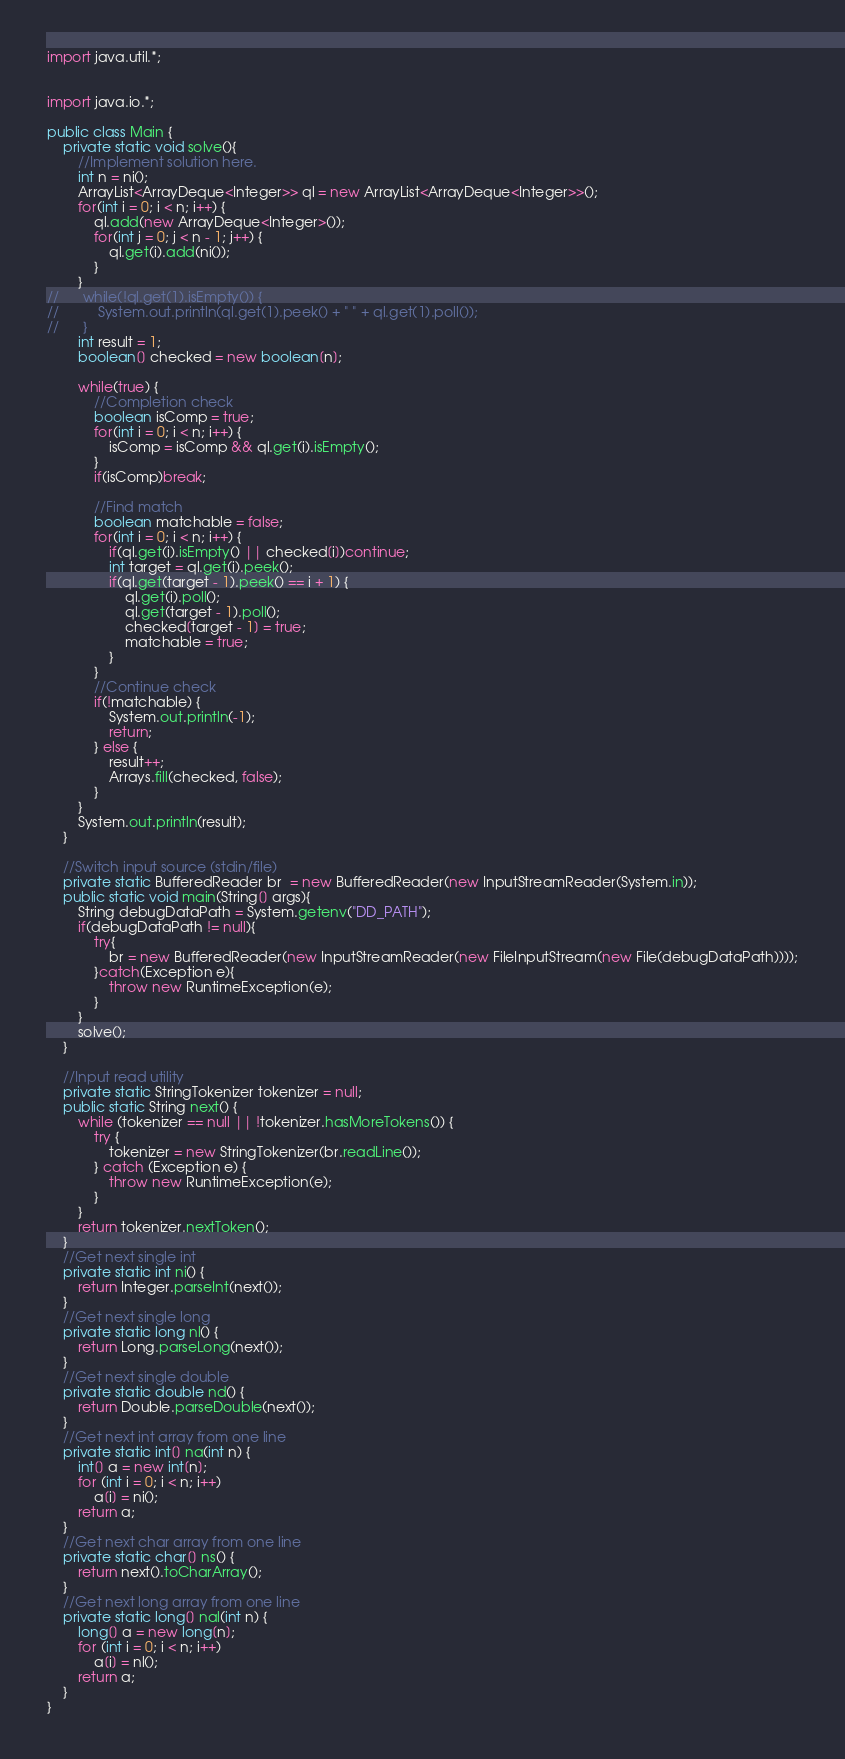<code> <loc_0><loc_0><loc_500><loc_500><_Java_>import java.util.*;


import java.io.*;

public class Main {
	private static void solve(){
		//Implement solution here.
		int n = ni();
		ArrayList<ArrayDeque<Integer>> ql = new ArrayList<ArrayDeque<Integer>>();
		for(int i = 0; i < n; i++) {
			ql.add(new ArrayDeque<Integer>());
			for(int j = 0; j < n - 1; j++) {
				ql.get(i).add(ni());
			}
		}
//		while(!ql.get(1).isEmpty()) {
//			System.out.println(ql.get(1).peek() + " " + ql.get(1).poll());
//		}
		int result = 1;
		boolean[] checked = new boolean[n];
		
		while(true) {
			//Completion check
			boolean isComp = true;
			for(int i = 0; i < n; i++) {
				isComp = isComp && ql.get(i).isEmpty();
			}
			if(isComp)break;
			
			//Find match
			boolean matchable = false;			
			for(int i = 0; i < n; i++) {
				if(ql.get(i).isEmpty() || checked[i])continue;
				int target = ql.get(i).peek();
				if(ql.get(target - 1).peek() == i + 1) {
					ql.get(i).poll();
					ql.get(target - 1).poll();
					checked[target - 1] = true;
					matchable = true;
				}
			}
			//Continue check
			if(!matchable) {
				System.out.println(-1);
				return;
			} else {
				result++;
				Arrays.fill(checked, false);
			}			
		}
		System.out.println(result);
	}

	//Switch input source (stdin/file)
	private static BufferedReader br  = new BufferedReader(new InputStreamReader(System.in));
	public static void main(String[] args){
		String debugDataPath = System.getenv("DD_PATH");        
		if(debugDataPath != null){
			try{
				br = new BufferedReader(new InputStreamReader(new FileInputStream(new File(debugDataPath))));
			}catch(Exception e){
				throw new RuntimeException(e);
			}
		} 
		solve();
	}

	//Input read utility
	private static StringTokenizer tokenizer = null;
	public static String next() {
		while (tokenizer == null || !tokenizer.hasMoreTokens()) {
			try {
				tokenizer = new StringTokenizer(br.readLine());
			} catch (Exception e) {
				throw new RuntimeException(e);
			}
		}
		return tokenizer.nextToken();
	}
	//Get next single int
	private static int ni() {
		return Integer.parseInt(next());
	}
	//Get next single long
	private static long nl() {
		return Long.parseLong(next());
	}
	//Get next single double
	private static double nd() {
		return Double.parseDouble(next());
	}
	//Get next int array from one line
	private static int[] na(int n) {
		int[] a = new int[n];
		for (int i = 0; i < n; i++)
			a[i] = ni();
		return a;
	}
	//Get next char array from one line
	private static char[] ns() {
		return next().toCharArray();
	}
	//Get next long array from one line
	private static long[] nal(int n) {
		long[] a = new long[n];
		for (int i = 0; i < n; i++)
			a[i] = nl();
		return a;
	}
}</code> 